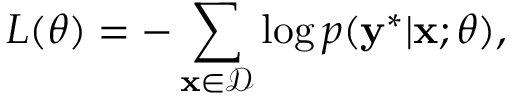Convert formula to latex. <formula><loc_0><loc_0><loc_500><loc_500>L ( \theta ) = - \sum _ { x \in \mathcal { D } } \log p ( y ^ { * } | x ; \theta ) ,</formula> 